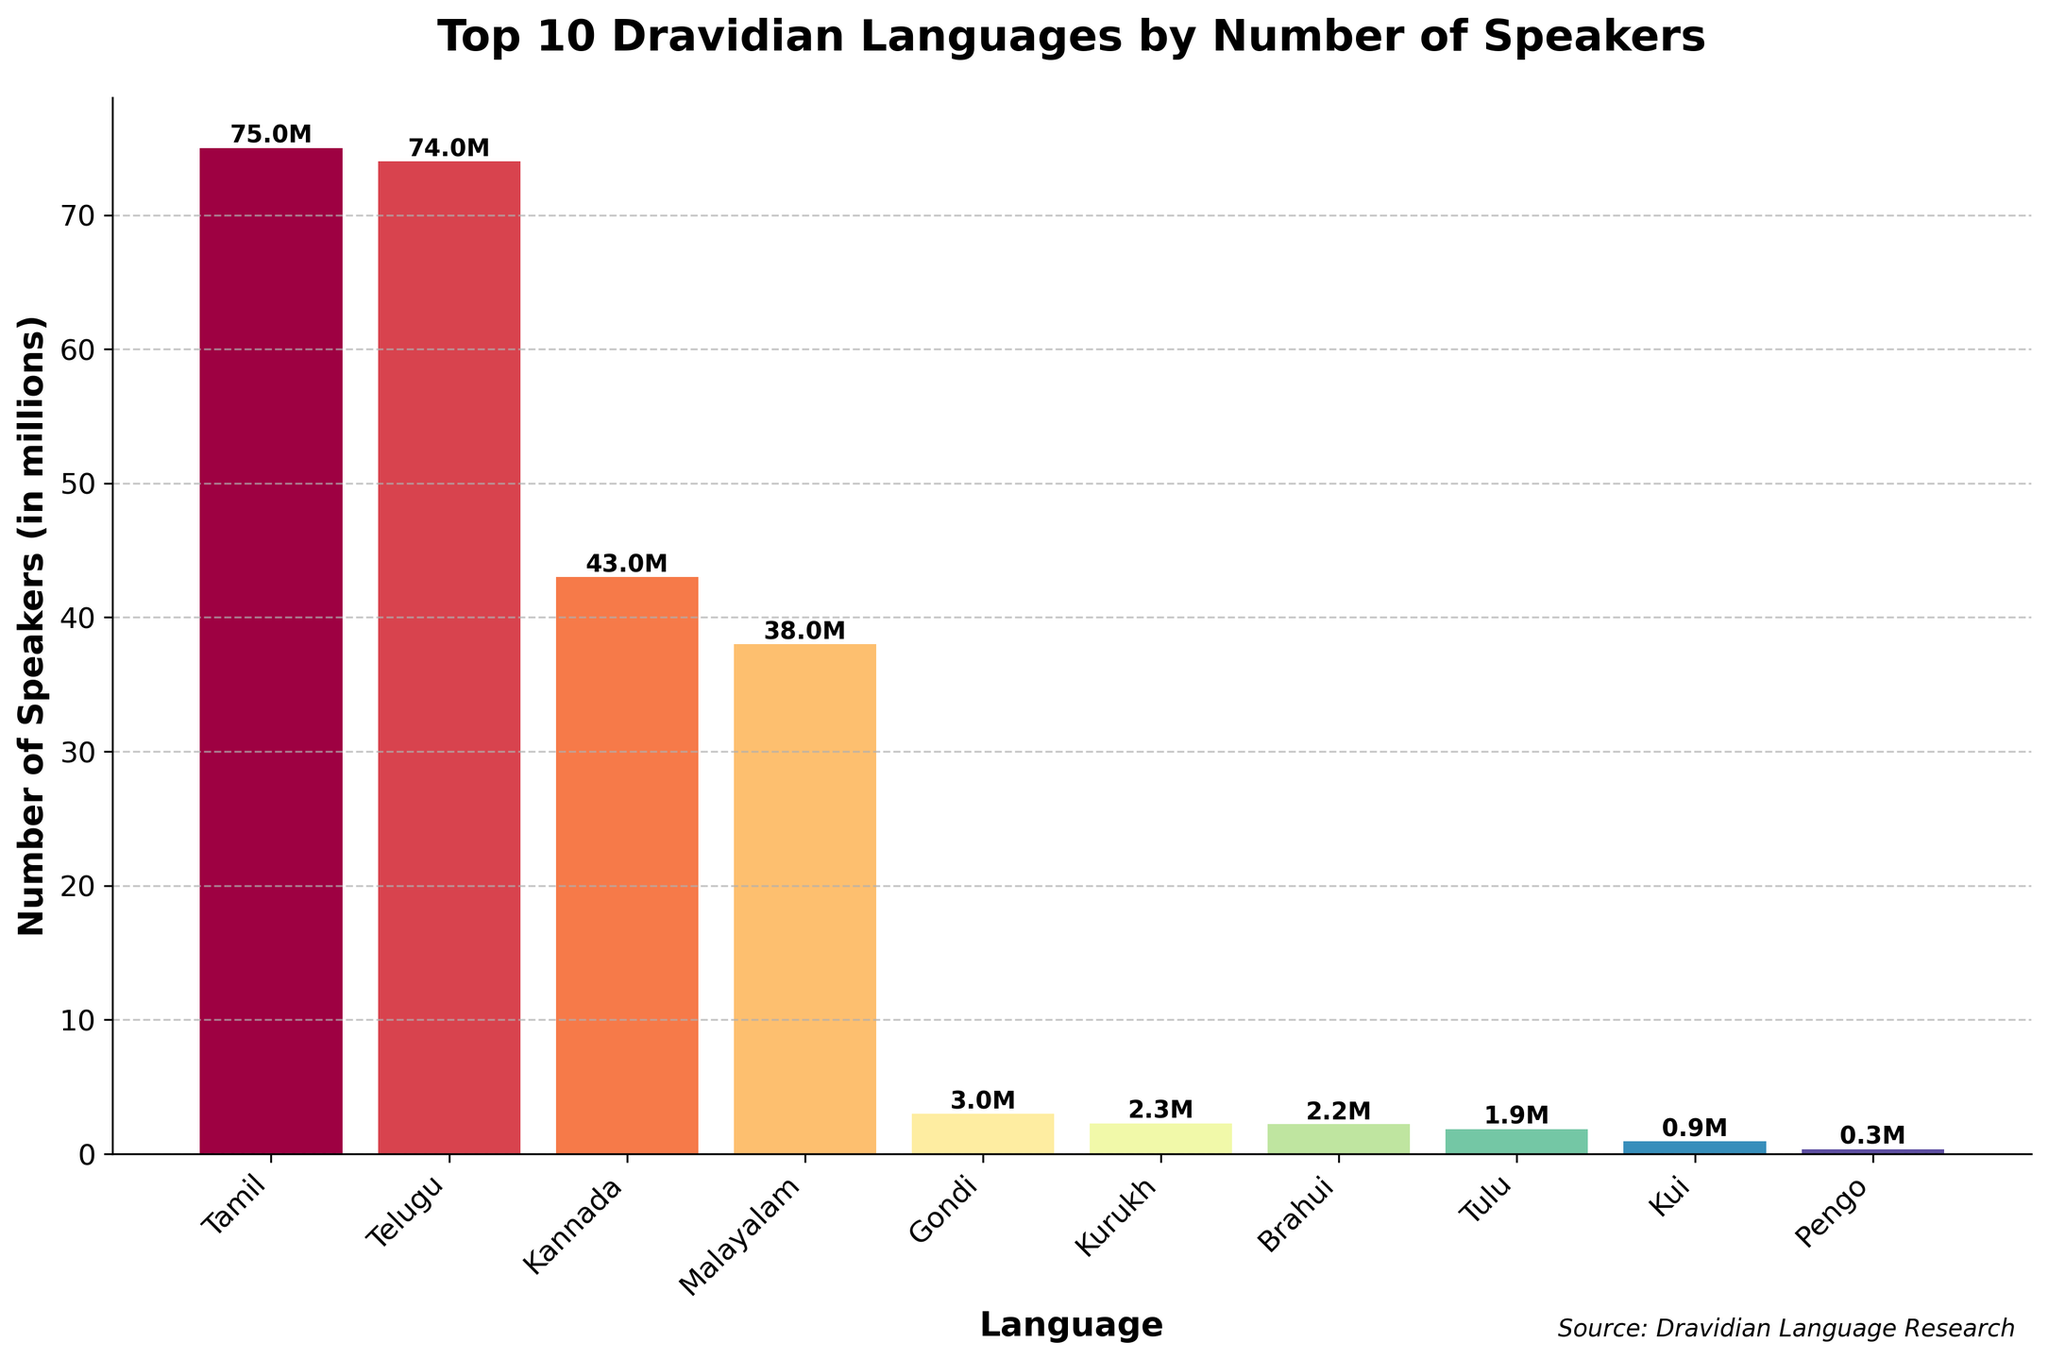Which language has the highest number of speakers? Look at the height of the bars on the plot. The tallest bar represents the language with the highest number of speakers.
Answer: Tamil How many speakers does Malayalam have compared to Kannada? Find the height of the bars for Malayalam and Kannada. The plot shows 38 million speakers for Malayalam and 43 million for Kannada.
Answer: Kannada has 5 million more speakers than Malayalam What is the total number of speakers for Tamil and Telugu combined? Look at the individual bars for Tamil and Telugu, which represent 75 million and 74 million, respectively. Add these numbers together: 75 + 74 = 149 million.
Answer: 149 million Which language ranks fourth in terms of the number of speakers? Identify the fourth tallest bar in descending order from the tallest to shortest. The fourth bar represents Malayalam.
Answer: Malayalam What are the number of speakers for the language with the least speakers? Look at the shortest bar in the plot. This bar represents the language with the fewest speakers. The shortest bar is for Kota with 930 speakers.
Answer: 930 speakers How does the number of speakers for Tulu compare to Gondi? Look at the heights of the bars for Tulu and Gondi. The plot shows Tulu has 1.85 million speakers and Gondi has 2.98 million speakers. Gondi has more speakers than Tulu.
Answer: Gondi has more speakers than Tulu What is the average number of speakers for the top 5 Dravidian languages? Find the heights of the bars for the top 5 languages: Tamil (75 million), Telugu (74 million), Kannada (43 million), Malayalam (38 million), and Gondi (2.98 million). Sum these numbers and divide by 5: (75 + 74 + 43 + 38 + 2.98) / 5 = 46.196 million.
Answer: 46.196 million Which language has just over 1 million speakers? Look at the bars slightly above the 1 million mark. The bar for Kui represents 941,000 speakers, slightly over 1 million.
Answer: Kui 